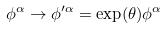<formula> <loc_0><loc_0><loc_500><loc_500>\phi ^ { \alpha } \rightarrow \phi ^ { \prime \alpha } = \exp ( \theta ) \phi ^ { \alpha }</formula> 